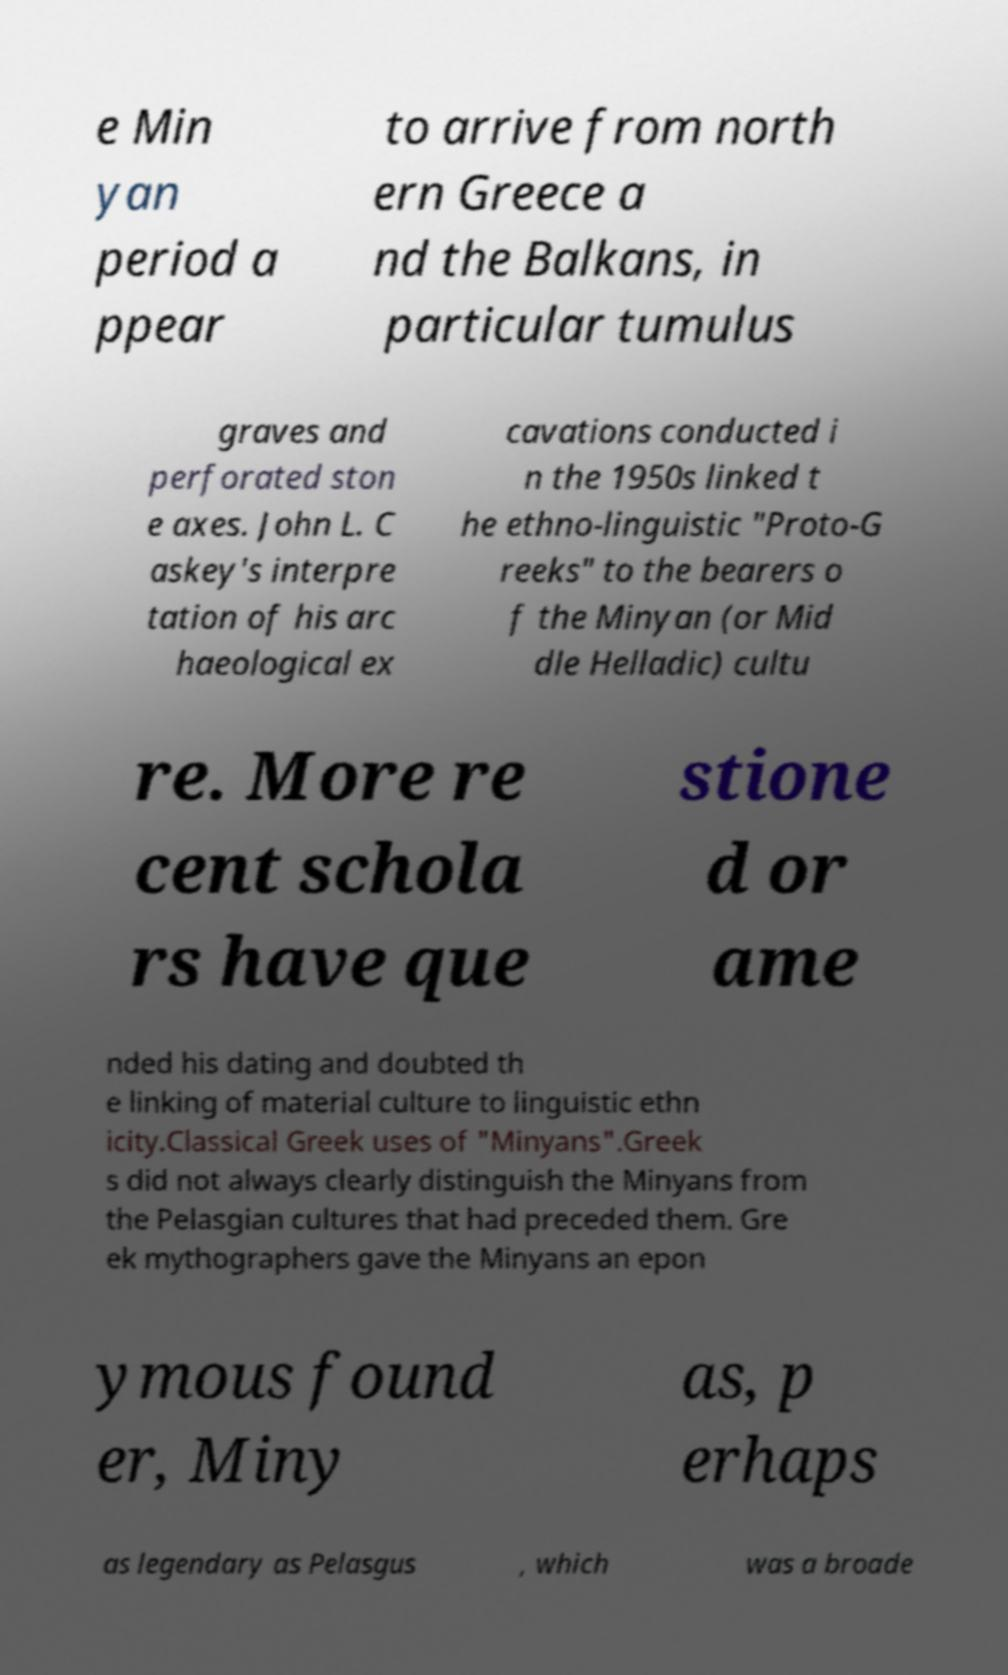Could you extract and type out the text from this image? e Min yan period a ppear to arrive from north ern Greece a nd the Balkans, in particular tumulus graves and perforated ston e axes. John L. C askey's interpre tation of his arc haeological ex cavations conducted i n the 1950s linked t he ethno-linguistic "Proto-G reeks" to the bearers o f the Minyan (or Mid dle Helladic) cultu re. More re cent schola rs have que stione d or ame nded his dating and doubted th e linking of material culture to linguistic ethn icity.Classical Greek uses of "Minyans".Greek s did not always clearly distinguish the Minyans from the Pelasgian cultures that had preceded them. Gre ek mythographers gave the Minyans an epon ymous found er, Miny as, p erhaps as legendary as Pelasgus , which was a broade 